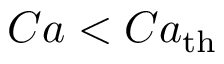<formula> <loc_0><loc_0><loc_500><loc_500>C a < C a _ { t h }</formula> 